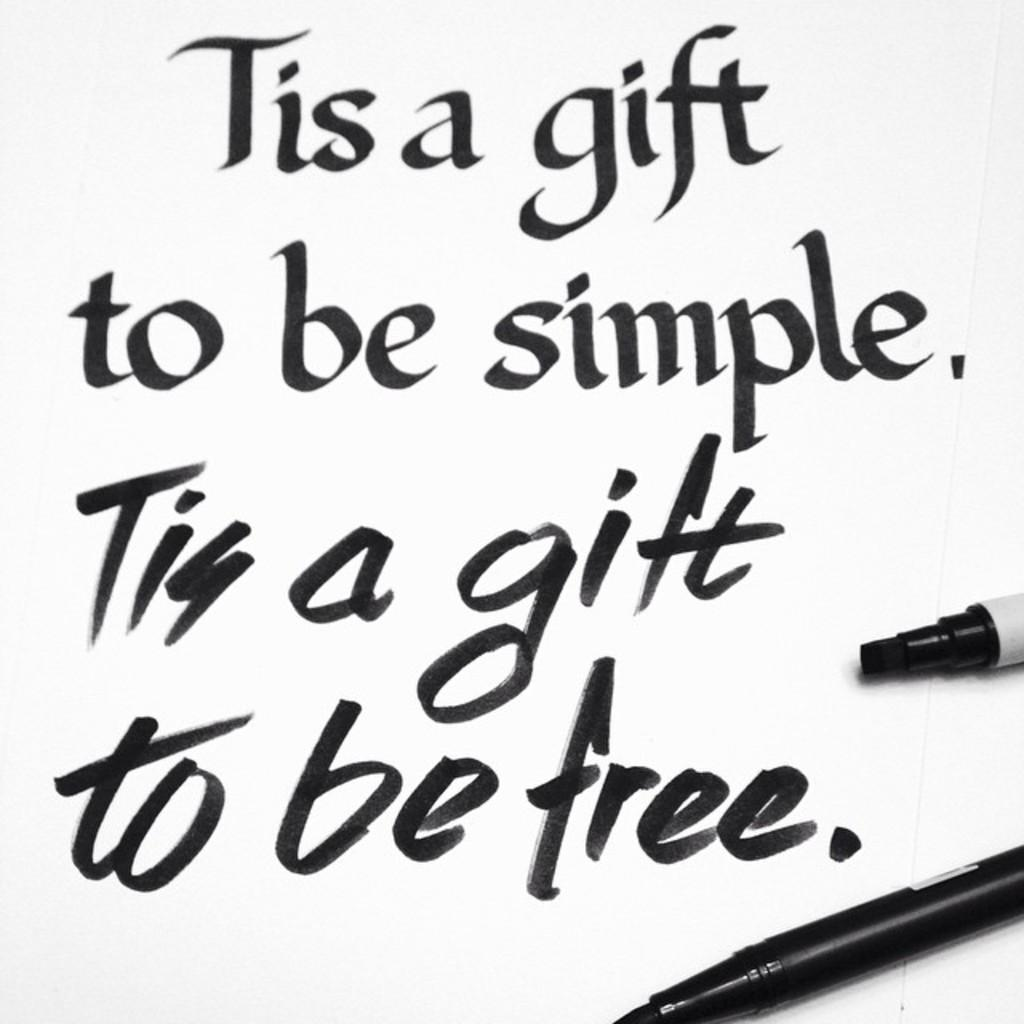What writing instruments are visible in the image? There are markers and pens in the image. What is the surface on which the text is written in the image? The text is written on a white color surface in the image. How many eyes can be seen on the fairies in the image? There are no fairies present in the image, so it is not possible to determine the number of eyes on them. What type of cloud is visible in the image? There is no cloud present in the image. 